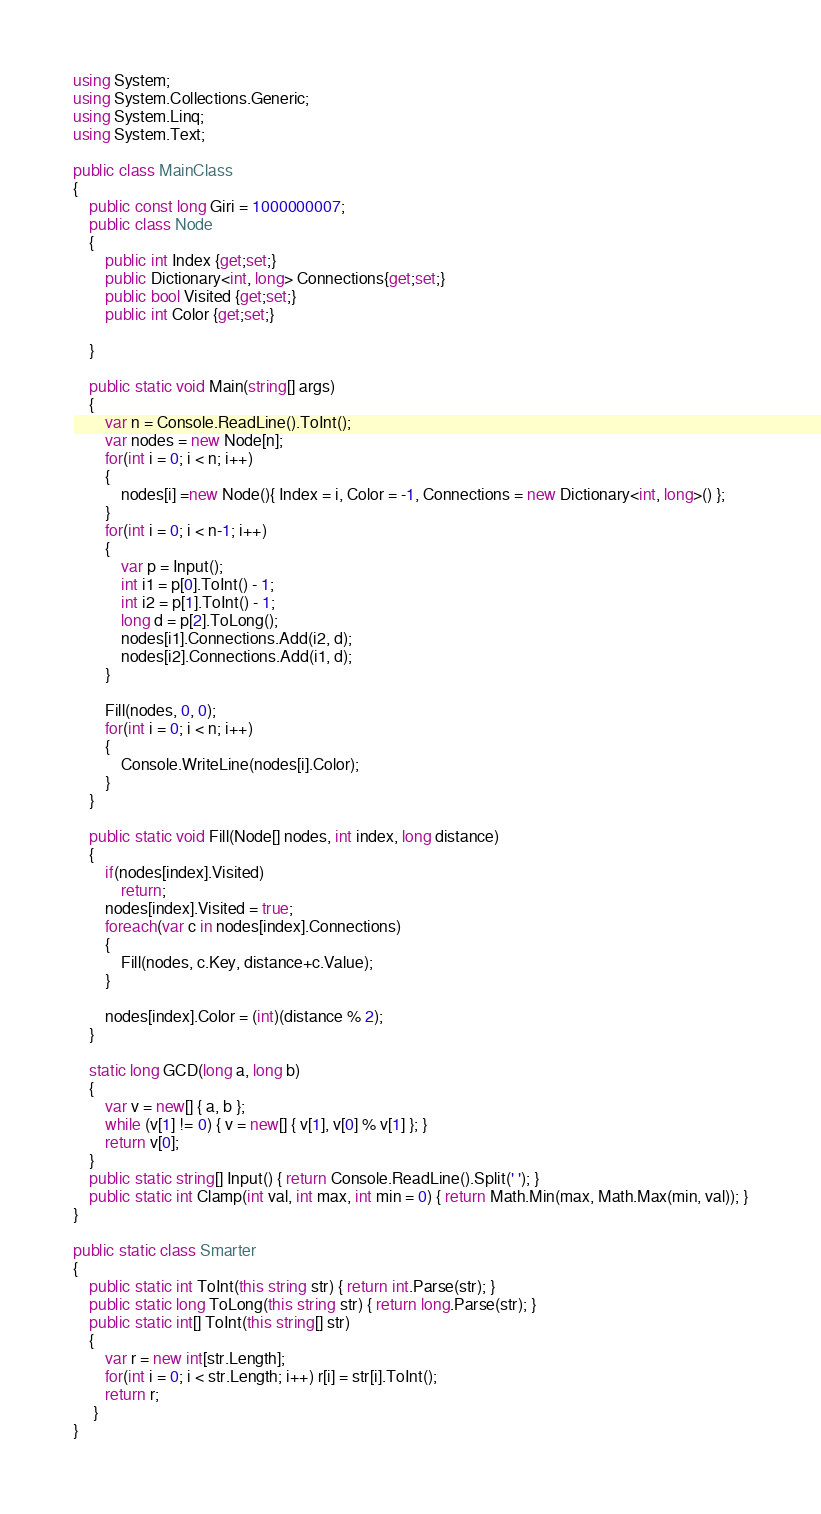Convert code to text. <code><loc_0><loc_0><loc_500><loc_500><_C#_>using System;
using System.Collections.Generic;
using System.Linq;
using System.Text;

public class MainClass
{
	public const long Giri = 1000000007;
	public class Node
	{
		public int Index {get;set;}
		public Dictionary<int, long> Connections{get;set;}
		public bool Visited {get;set;}
		public int Color {get;set;}
		
	}
	
	public static void Main(string[] args)
	{
		var n = Console.ReadLine().ToInt();
		var nodes = new Node[n];
		for(int i = 0; i < n; i++)
		{
			nodes[i] =new Node(){ Index = i, Color = -1, Connections = new Dictionary<int, long>() };
		}
		for(int i = 0; i < n-1; i++)
		{
			var p = Input();
			int i1 = p[0].ToInt() - 1;
			int i2 = p[1].ToInt() - 1;
			long d = p[2].ToLong();
			nodes[i1].Connections.Add(i2, d);
			nodes[i2].Connections.Add(i1, d);
		}
		
		Fill(nodes, 0, 0);
		for(int i = 0; i < n; i++)
		{
			Console.WriteLine(nodes[i].Color);
		}
	}
	
	public static void Fill(Node[] nodes, int index, long distance)
	{
		if(nodes[index].Visited)
			return;
		nodes[index].Visited = true;
		foreach(var c in nodes[index].Connections)
		{
			Fill(nodes, c.Key, distance+c.Value);
		}
		
		nodes[index].Color = (int)(distance % 2);
	}
	
	static long GCD(long a, long b)
	{
		var v = new[] { a, b };
		while (v[1] != 0) { v = new[] { v[1], v[0] % v[1] }; }
		return v[0];
	}
	public static string[] Input() { return Console.ReadLine().Split(' '); }
	public static int Clamp(int val, int max, int min = 0) { return Math.Min(max, Math.Max(min, val)); }
}

public static class Smarter
{
	public static int ToInt(this string str) { return int.Parse(str); }
	public static long ToLong(this string str) { return long.Parse(str); }
	public static int[] ToInt(this string[] str)
	{
		var r = new int[str.Length];
		for(int i = 0; i < str.Length; i++) r[i] = str[i].ToInt();
		return r;
	 }
}

</code> 